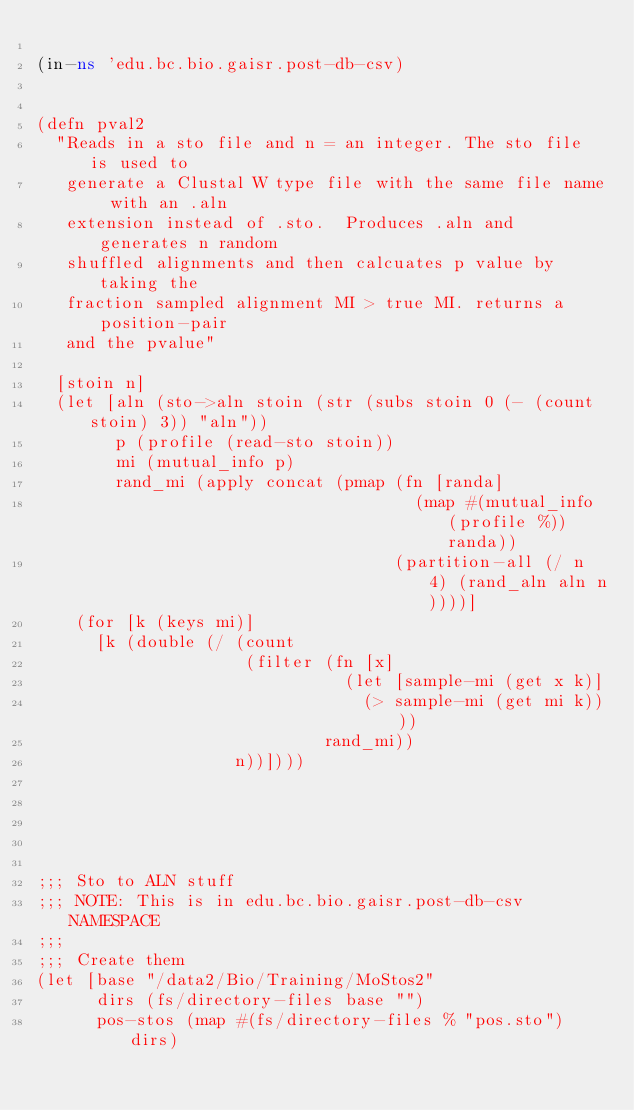Convert code to text. <code><loc_0><loc_0><loc_500><loc_500><_Clojure_>
(in-ns 'edu.bc.bio.gaisr.post-db-csv)


(defn pval2
  "Reads in a sto file and n = an integer. The sto file is used to
   generate a Clustal W type file with the same file name with an .aln
   extension instead of .sto.  Produces .aln and generates n random
   shuffled alignments and then calcuates p value by taking the
   fraction sampled alignment MI > true MI. returns a position-pair
   and the pvalue"

  [stoin n]
  (let [aln (sto->aln stoin (str (subs stoin 0 (- (count stoin) 3)) "aln"))
        p (profile (read-sto stoin))
        mi (mutual_info p)
        rand_mi (apply concat (pmap (fn [randa]
                                      (map #(mutual_info (profile %)) randa))
                                    (partition-all (/ n 4) (rand_aln aln n))))]
    (for [k (keys mi)]
      [k (double (/ (count
                     (filter (fn [x]
                               (let [sample-mi (get x k)]
                                 (> sample-mi (get mi k))))
                             rand_mi))
                    n))])))





;;; Sto to ALN stuff
;;; NOTE: This is in edu.bc.bio.gaisr.post-db-csv NAMESPACE
;;;
;;; Create them
(let [base "/data2/Bio/Training/MoStos2"
      dirs (fs/directory-files base "")
      pos-stos (map #(fs/directory-files % "pos.sto") dirs)</code> 